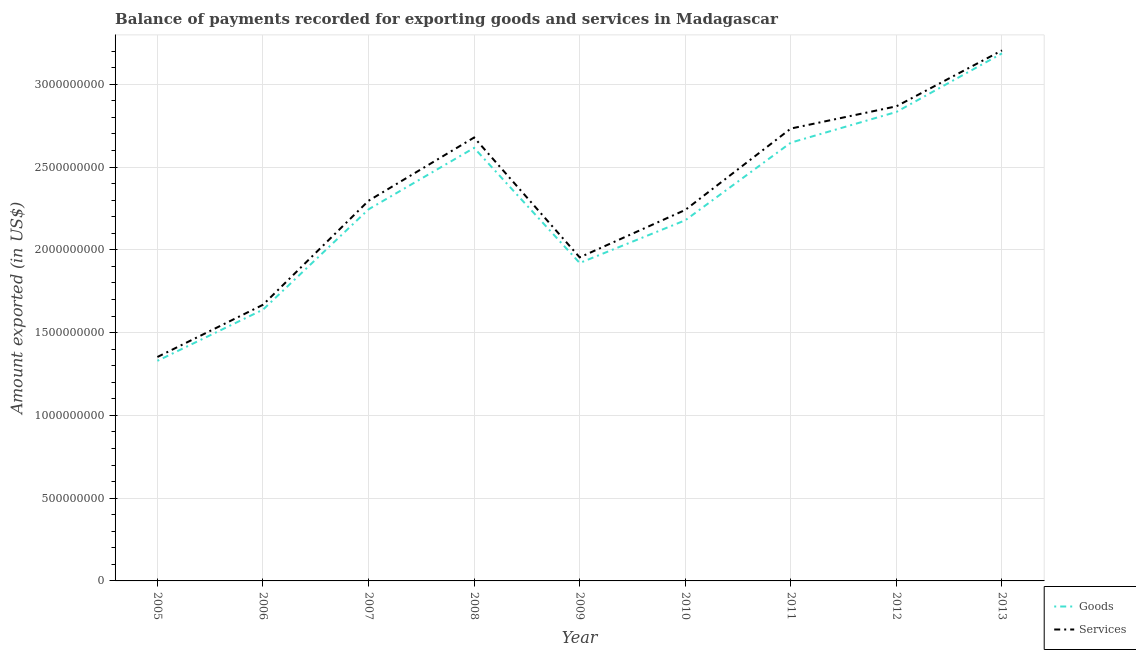Is the number of lines equal to the number of legend labels?
Your answer should be very brief. Yes. What is the amount of goods exported in 2005?
Ensure brevity in your answer.  1.33e+09. Across all years, what is the maximum amount of goods exported?
Give a very brief answer. 3.19e+09. Across all years, what is the minimum amount of goods exported?
Keep it short and to the point. 1.33e+09. What is the total amount of services exported in the graph?
Provide a short and direct response. 2.10e+1. What is the difference between the amount of goods exported in 2008 and that in 2010?
Keep it short and to the point. 4.37e+08. What is the difference between the amount of goods exported in 2007 and the amount of services exported in 2011?
Your response must be concise. -4.88e+08. What is the average amount of goods exported per year?
Keep it short and to the point. 2.29e+09. In the year 2013, what is the difference between the amount of goods exported and amount of services exported?
Keep it short and to the point. -1.80e+07. What is the ratio of the amount of goods exported in 2008 to that in 2009?
Provide a short and direct response. 1.36. Is the difference between the amount of services exported in 2009 and 2010 greater than the difference between the amount of goods exported in 2009 and 2010?
Offer a very short reply. No. What is the difference between the highest and the second highest amount of goods exported?
Give a very brief answer. 3.54e+08. What is the difference between the highest and the lowest amount of goods exported?
Your answer should be compact. 1.86e+09. In how many years, is the amount of services exported greater than the average amount of services exported taken over all years?
Give a very brief answer. 4. Is the sum of the amount of services exported in 2007 and 2010 greater than the maximum amount of goods exported across all years?
Provide a succinct answer. Yes. Does the amount of services exported monotonically increase over the years?
Provide a short and direct response. No. Is the amount of services exported strictly less than the amount of goods exported over the years?
Keep it short and to the point. No. How many lines are there?
Make the answer very short. 2. Does the graph contain any zero values?
Offer a terse response. No. Where does the legend appear in the graph?
Your answer should be very brief. Bottom right. How many legend labels are there?
Your answer should be very brief. 2. How are the legend labels stacked?
Ensure brevity in your answer.  Vertical. What is the title of the graph?
Provide a short and direct response. Balance of payments recorded for exporting goods and services in Madagascar. What is the label or title of the X-axis?
Give a very brief answer. Year. What is the label or title of the Y-axis?
Provide a succinct answer. Amount exported (in US$). What is the Amount exported (in US$) of Goods in 2005?
Make the answer very short. 1.33e+09. What is the Amount exported (in US$) in Services in 2005?
Your response must be concise. 1.35e+09. What is the Amount exported (in US$) of Goods in 2006?
Offer a terse response. 1.64e+09. What is the Amount exported (in US$) in Services in 2006?
Provide a succinct answer. 1.67e+09. What is the Amount exported (in US$) in Goods in 2007?
Offer a very short reply. 2.24e+09. What is the Amount exported (in US$) of Services in 2007?
Provide a succinct answer. 2.30e+09. What is the Amount exported (in US$) in Goods in 2008?
Your answer should be compact. 2.62e+09. What is the Amount exported (in US$) in Services in 2008?
Provide a succinct answer. 2.68e+09. What is the Amount exported (in US$) in Goods in 2009?
Keep it short and to the point. 1.92e+09. What is the Amount exported (in US$) of Services in 2009?
Keep it short and to the point. 1.95e+09. What is the Amount exported (in US$) of Goods in 2010?
Your response must be concise. 2.18e+09. What is the Amount exported (in US$) of Services in 2010?
Offer a terse response. 2.24e+09. What is the Amount exported (in US$) of Goods in 2011?
Offer a terse response. 2.65e+09. What is the Amount exported (in US$) of Services in 2011?
Ensure brevity in your answer.  2.73e+09. What is the Amount exported (in US$) in Goods in 2012?
Offer a very short reply. 2.83e+09. What is the Amount exported (in US$) in Services in 2012?
Make the answer very short. 2.87e+09. What is the Amount exported (in US$) in Goods in 2013?
Offer a very short reply. 3.19e+09. What is the Amount exported (in US$) of Services in 2013?
Make the answer very short. 3.20e+09. Across all years, what is the maximum Amount exported (in US$) in Goods?
Provide a short and direct response. 3.19e+09. Across all years, what is the maximum Amount exported (in US$) of Services?
Ensure brevity in your answer.  3.20e+09. Across all years, what is the minimum Amount exported (in US$) in Goods?
Offer a terse response. 1.33e+09. Across all years, what is the minimum Amount exported (in US$) of Services?
Provide a short and direct response. 1.35e+09. What is the total Amount exported (in US$) in Goods in the graph?
Provide a short and direct response. 2.06e+1. What is the total Amount exported (in US$) of Services in the graph?
Provide a succinct answer. 2.10e+1. What is the difference between the Amount exported (in US$) in Goods in 2005 and that in 2006?
Ensure brevity in your answer.  -3.09e+08. What is the difference between the Amount exported (in US$) in Services in 2005 and that in 2006?
Your answer should be very brief. -3.15e+08. What is the difference between the Amount exported (in US$) in Goods in 2005 and that in 2007?
Your answer should be compact. -9.15e+08. What is the difference between the Amount exported (in US$) in Services in 2005 and that in 2007?
Offer a terse response. -9.44e+08. What is the difference between the Amount exported (in US$) in Goods in 2005 and that in 2008?
Ensure brevity in your answer.  -1.29e+09. What is the difference between the Amount exported (in US$) of Services in 2005 and that in 2008?
Your response must be concise. -1.33e+09. What is the difference between the Amount exported (in US$) of Goods in 2005 and that in 2009?
Your response must be concise. -5.91e+08. What is the difference between the Amount exported (in US$) in Services in 2005 and that in 2009?
Make the answer very short. -6.02e+08. What is the difference between the Amount exported (in US$) of Goods in 2005 and that in 2010?
Offer a very short reply. -8.49e+08. What is the difference between the Amount exported (in US$) in Services in 2005 and that in 2010?
Ensure brevity in your answer.  -8.88e+08. What is the difference between the Amount exported (in US$) in Goods in 2005 and that in 2011?
Provide a succinct answer. -1.32e+09. What is the difference between the Amount exported (in US$) of Services in 2005 and that in 2011?
Offer a very short reply. -1.38e+09. What is the difference between the Amount exported (in US$) in Goods in 2005 and that in 2012?
Offer a terse response. -1.50e+09. What is the difference between the Amount exported (in US$) in Services in 2005 and that in 2012?
Your answer should be compact. -1.51e+09. What is the difference between the Amount exported (in US$) in Goods in 2005 and that in 2013?
Your answer should be very brief. -1.86e+09. What is the difference between the Amount exported (in US$) in Services in 2005 and that in 2013?
Keep it short and to the point. -1.85e+09. What is the difference between the Amount exported (in US$) of Goods in 2006 and that in 2007?
Keep it short and to the point. -6.06e+08. What is the difference between the Amount exported (in US$) in Services in 2006 and that in 2007?
Your answer should be very brief. -6.28e+08. What is the difference between the Amount exported (in US$) in Goods in 2006 and that in 2008?
Your answer should be very brief. -9.77e+08. What is the difference between the Amount exported (in US$) in Services in 2006 and that in 2008?
Give a very brief answer. -1.01e+09. What is the difference between the Amount exported (in US$) in Goods in 2006 and that in 2009?
Make the answer very short. -2.82e+08. What is the difference between the Amount exported (in US$) in Services in 2006 and that in 2009?
Keep it short and to the point. -2.86e+08. What is the difference between the Amount exported (in US$) in Goods in 2006 and that in 2010?
Ensure brevity in your answer.  -5.40e+08. What is the difference between the Amount exported (in US$) of Services in 2006 and that in 2010?
Offer a very short reply. -5.73e+08. What is the difference between the Amount exported (in US$) of Goods in 2006 and that in 2011?
Provide a short and direct response. -1.01e+09. What is the difference between the Amount exported (in US$) in Services in 2006 and that in 2011?
Provide a short and direct response. -1.06e+09. What is the difference between the Amount exported (in US$) of Goods in 2006 and that in 2012?
Provide a succinct answer. -1.19e+09. What is the difference between the Amount exported (in US$) of Services in 2006 and that in 2012?
Your answer should be very brief. -1.20e+09. What is the difference between the Amount exported (in US$) in Goods in 2006 and that in 2013?
Ensure brevity in your answer.  -1.55e+09. What is the difference between the Amount exported (in US$) of Services in 2006 and that in 2013?
Provide a short and direct response. -1.54e+09. What is the difference between the Amount exported (in US$) of Goods in 2007 and that in 2008?
Your answer should be very brief. -3.71e+08. What is the difference between the Amount exported (in US$) of Services in 2007 and that in 2008?
Provide a succinct answer. -3.82e+08. What is the difference between the Amount exported (in US$) of Goods in 2007 and that in 2009?
Offer a very short reply. 3.24e+08. What is the difference between the Amount exported (in US$) of Services in 2007 and that in 2009?
Ensure brevity in your answer.  3.42e+08. What is the difference between the Amount exported (in US$) of Goods in 2007 and that in 2010?
Your answer should be compact. 6.62e+07. What is the difference between the Amount exported (in US$) of Services in 2007 and that in 2010?
Keep it short and to the point. 5.55e+07. What is the difference between the Amount exported (in US$) in Goods in 2007 and that in 2011?
Ensure brevity in your answer.  -4.03e+08. What is the difference between the Amount exported (in US$) of Services in 2007 and that in 2011?
Keep it short and to the point. -4.36e+08. What is the difference between the Amount exported (in US$) in Goods in 2007 and that in 2012?
Your answer should be very brief. -5.88e+08. What is the difference between the Amount exported (in US$) of Services in 2007 and that in 2012?
Provide a succinct answer. -5.70e+08. What is the difference between the Amount exported (in US$) of Goods in 2007 and that in 2013?
Keep it short and to the point. -9.42e+08. What is the difference between the Amount exported (in US$) of Services in 2007 and that in 2013?
Your answer should be very brief. -9.08e+08. What is the difference between the Amount exported (in US$) in Goods in 2008 and that in 2009?
Provide a succinct answer. 6.95e+08. What is the difference between the Amount exported (in US$) in Services in 2008 and that in 2009?
Provide a short and direct response. 7.24e+08. What is the difference between the Amount exported (in US$) of Goods in 2008 and that in 2010?
Provide a short and direct response. 4.37e+08. What is the difference between the Amount exported (in US$) of Services in 2008 and that in 2010?
Keep it short and to the point. 4.38e+08. What is the difference between the Amount exported (in US$) in Goods in 2008 and that in 2011?
Provide a succinct answer. -3.17e+07. What is the difference between the Amount exported (in US$) in Services in 2008 and that in 2011?
Provide a succinct answer. -5.41e+07. What is the difference between the Amount exported (in US$) in Goods in 2008 and that in 2012?
Offer a very short reply. -2.17e+08. What is the difference between the Amount exported (in US$) in Services in 2008 and that in 2012?
Give a very brief answer. -1.88e+08. What is the difference between the Amount exported (in US$) of Goods in 2008 and that in 2013?
Offer a terse response. -5.71e+08. What is the difference between the Amount exported (in US$) of Services in 2008 and that in 2013?
Offer a very short reply. -5.26e+08. What is the difference between the Amount exported (in US$) of Goods in 2009 and that in 2010?
Your answer should be compact. -2.58e+08. What is the difference between the Amount exported (in US$) in Services in 2009 and that in 2010?
Your answer should be compact. -2.87e+08. What is the difference between the Amount exported (in US$) of Goods in 2009 and that in 2011?
Your answer should be very brief. -7.27e+08. What is the difference between the Amount exported (in US$) in Services in 2009 and that in 2011?
Your response must be concise. -7.78e+08. What is the difference between the Amount exported (in US$) of Goods in 2009 and that in 2012?
Make the answer very short. -9.12e+08. What is the difference between the Amount exported (in US$) of Services in 2009 and that in 2012?
Provide a succinct answer. -9.12e+08. What is the difference between the Amount exported (in US$) of Goods in 2009 and that in 2013?
Keep it short and to the point. -1.27e+09. What is the difference between the Amount exported (in US$) in Services in 2009 and that in 2013?
Keep it short and to the point. -1.25e+09. What is the difference between the Amount exported (in US$) in Goods in 2010 and that in 2011?
Your answer should be compact. -4.69e+08. What is the difference between the Amount exported (in US$) of Services in 2010 and that in 2011?
Offer a very short reply. -4.92e+08. What is the difference between the Amount exported (in US$) of Goods in 2010 and that in 2012?
Offer a very short reply. -6.54e+08. What is the difference between the Amount exported (in US$) in Services in 2010 and that in 2012?
Your answer should be very brief. -6.26e+08. What is the difference between the Amount exported (in US$) of Goods in 2010 and that in 2013?
Ensure brevity in your answer.  -1.01e+09. What is the difference between the Amount exported (in US$) of Services in 2010 and that in 2013?
Ensure brevity in your answer.  -9.64e+08. What is the difference between the Amount exported (in US$) in Goods in 2011 and that in 2012?
Make the answer very short. -1.86e+08. What is the difference between the Amount exported (in US$) in Services in 2011 and that in 2012?
Provide a succinct answer. -1.34e+08. What is the difference between the Amount exported (in US$) of Goods in 2011 and that in 2013?
Provide a succinct answer. -5.39e+08. What is the difference between the Amount exported (in US$) in Services in 2011 and that in 2013?
Provide a succinct answer. -4.72e+08. What is the difference between the Amount exported (in US$) in Goods in 2012 and that in 2013?
Make the answer very short. -3.54e+08. What is the difference between the Amount exported (in US$) of Services in 2012 and that in 2013?
Give a very brief answer. -3.38e+08. What is the difference between the Amount exported (in US$) in Goods in 2005 and the Amount exported (in US$) in Services in 2006?
Your answer should be compact. -3.39e+08. What is the difference between the Amount exported (in US$) of Goods in 2005 and the Amount exported (in US$) of Services in 2007?
Provide a short and direct response. -9.67e+08. What is the difference between the Amount exported (in US$) in Goods in 2005 and the Amount exported (in US$) in Services in 2008?
Ensure brevity in your answer.  -1.35e+09. What is the difference between the Amount exported (in US$) of Goods in 2005 and the Amount exported (in US$) of Services in 2009?
Offer a terse response. -6.25e+08. What is the difference between the Amount exported (in US$) in Goods in 2005 and the Amount exported (in US$) in Services in 2010?
Offer a very short reply. -9.12e+08. What is the difference between the Amount exported (in US$) of Goods in 2005 and the Amount exported (in US$) of Services in 2011?
Your answer should be very brief. -1.40e+09. What is the difference between the Amount exported (in US$) of Goods in 2005 and the Amount exported (in US$) of Services in 2012?
Make the answer very short. -1.54e+09. What is the difference between the Amount exported (in US$) in Goods in 2005 and the Amount exported (in US$) in Services in 2013?
Offer a terse response. -1.88e+09. What is the difference between the Amount exported (in US$) in Goods in 2006 and the Amount exported (in US$) in Services in 2007?
Your answer should be compact. -6.58e+08. What is the difference between the Amount exported (in US$) of Goods in 2006 and the Amount exported (in US$) of Services in 2008?
Provide a short and direct response. -1.04e+09. What is the difference between the Amount exported (in US$) in Goods in 2006 and the Amount exported (in US$) in Services in 2009?
Provide a succinct answer. -3.16e+08. What is the difference between the Amount exported (in US$) in Goods in 2006 and the Amount exported (in US$) in Services in 2010?
Your answer should be compact. -6.02e+08. What is the difference between the Amount exported (in US$) in Goods in 2006 and the Amount exported (in US$) in Services in 2011?
Make the answer very short. -1.09e+09. What is the difference between the Amount exported (in US$) of Goods in 2006 and the Amount exported (in US$) of Services in 2012?
Your answer should be compact. -1.23e+09. What is the difference between the Amount exported (in US$) of Goods in 2006 and the Amount exported (in US$) of Services in 2013?
Ensure brevity in your answer.  -1.57e+09. What is the difference between the Amount exported (in US$) in Goods in 2007 and the Amount exported (in US$) in Services in 2008?
Provide a succinct answer. -4.34e+08. What is the difference between the Amount exported (in US$) of Goods in 2007 and the Amount exported (in US$) of Services in 2009?
Provide a succinct answer. 2.90e+08. What is the difference between the Amount exported (in US$) of Goods in 2007 and the Amount exported (in US$) of Services in 2010?
Provide a short and direct response. 3.66e+06. What is the difference between the Amount exported (in US$) in Goods in 2007 and the Amount exported (in US$) in Services in 2011?
Make the answer very short. -4.88e+08. What is the difference between the Amount exported (in US$) of Goods in 2007 and the Amount exported (in US$) of Services in 2012?
Provide a short and direct response. -6.22e+08. What is the difference between the Amount exported (in US$) of Goods in 2007 and the Amount exported (in US$) of Services in 2013?
Provide a succinct answer. -9.60e+08. What is the difference between the Amount exported (in US$) in Goods in 2008 and the Amount exported (in US$) in Services in 2009?
Offer a very short reply. 6.61e+08. What is the difference between the Amount exported (in US$) in Goods in 2008 and the Amount exported (in US$) in Services in 2010?
Your response must be concise. 3.75e+08. What is the difference between the Amount exported (in US$) in Goods in 2008 and the Amount exported (in US$) in Services in 2011?
Keep it short and to the point. -1.17e+08. What is the difference between the Amount exported (in US$) of Goods in 2008 and the Amount exported (in US$) of Services in 2012?
Keep it short and to the point. -2.51e+08. What is the difference between the Amount exported (in US$) of Goods in 2008 and the Amount exported (in US$) of Services in 2013?
Make the answer very short. -5.89e+08. What is the difference between the Amount exported (in US$) in Goods in 2009 and the Amount exported (in US$) in Services in 2010?
Make the answer very short. -3.20e+08. What is the difference between the Amount exported (in US$) in Goods in 2009 and the Amount exported (in US$) in Services in 2011?
Your answer should be compact. -8.12e+08. What is the difference between the Amount exported (in US$) of Goods in 2009 and the Amount exported (in US$) of Services in 2012?
Your response must be concise. -9.46e+08. What is the difference between the Amount exported (in US$) in Goods in 2009 and the Amount exported (in US$) in Services in 2013?
Ensure brevity in your answer.  -1.28e+09. What is the difference between the Amount exported (in US$) in Goods in 2010 and the Amount exported (in US$) in Services in 2011?
Your answer should be compact. -5.54e+08. What is the difference between the Amount exported (in US$) in Goods in 2010 and the Amount exported (in US$) in Services in 2012?
Provide a succinct answer. -6.88e+08. What is the difference between the Amount exported (in US$) of Goods in 2010 and the Amount exported (in US$) of Services in 2013?
Keep it short and to the point. -1.03e+09. What is the difference between the Amount exported (in US$) of Goods in 2011 and the Amount exported (in US$) of Services in 2012?
Keep it short and to the point. -2.20e+08. What is the difference between the Amount exported (in US$) of Goods in 2011 and the Amount exported (in US$) of Services in 2013?
Provide a succinct answer. -5.57e+08. What is the difference between the Amount exported (in US$) in Goods in 2012 and the Amount exported (in US$) in Services in 2013?
Keep it short and to the point. -3.72e+08. What is the average Amount exported (in US$) of Goods per year?
Offer a very short reply. 2.29e+09. What is the average Amount exported (in US$) of Services per year?
Your answer should be compact. 2.33e+09. In the year 2005, what is the difference between the Amount exported (in US$) in Goods and Amount exported (in US$) in Services?
Your response must be concise. -2.32e+07. In the year 2006, what is the difference between the Amount exported (in US$) of Goods and Amount exported (in US$) of Services?
Keep it short and to the point. -2.95e+07. In the year 2007, what is the difference between the Amount exported (in US$) in Goods and Amount exported (in US$) in Services?
Provide a short and direct response. -5.18e+07. In the year 2008, what is the difference between the Amount exported (in US$) of Goods and Amount exported (in US$) of Services?
Give a very brief answer. -6.28e+07. In the year 2009, what is the difference between the Amount exported (in US$) of Goods and Amount exported (in US$) of Services?
Provide a short and direct response. -3.39e+07. In the year 2010, what is the difference between the Amount exported (in US$) in Goods and Amount exported (in US$) in Services?
Offer a terse response. -6.25e+07. In the year 2011, what is the difference between the Amount exported (in US$) of Goods and Amount exported (in US$) of Services?
Give a very brief answer. -8.52e+07. In the year 2012, what is the difference between the Amount exported (in US$) of Goods and Amount exported (in US$) of Services?
Provide a succinct answer. -3.40e+07. In the year 2013, what is the difference between the Amount exported (in US$) of Goods and Amount exported (in US$) of Services?
Give a very brief answer. -1.80e+07. What is the ratio of the Amount exported (in US$) of Goods in 2005 to that in 2006?
Give a very brief answer. 0.81. What is the ratio of the Amount exported (in US$) in Services in 2005 to that in 2006?
Make the answer very short. 0.81. What is the ratio of the Amount exported (in US$) in Goods in 2005 to that in 2007?
Make the answer very short. 0.59. What is the ratio of the Amount exported (in US$) of Services in 2005 to that in 2007?
Your answer should be very brief. 0.59. What is the ratio of the Amount exported (in US$) of Goods in 2005 to that in 2008?
Provide a succinct answer. 0.51. What is the ratio of the Amount exported (in US$) in Services in 2005 to that in 2008?
Offer a terse response. 0.51. What is the ratio of the Amount exported (in US$) of Goods in 2005 to that in 2009?
Give a very brief answer. 0.69. What is the ratio of the Amount exported (in US$) in Services in 2005 to that in 2009?
Your answer should be compact. 0.69. What is the ratio of the Amount exported (in US$) in Goods in 2005 to that in 2010?
Offer a terse response. 0.61. What is the ratio of the Amount exported (in US$) in Services in 2005 to that in 2010?
Your answer should be very brief. 0.6. What is the ratio of the Amount exported (in US$) in Goods in 2005 to that in 2011?
Ensure brevity in your answer.  0.5. What is the ratio of the Amount exported (in US$) of Services in 2005 to that in 2011?
Give a very brief answer. 0.49. What is the ratio of the Amount exported (in US$) in Goods in 2005 to that in 2012?
Offer a terse response. 0.47. What is the ratio of the Amount exported (in US$) in Services in 2005 to that in 2012?
Offer a terse response. 0.47. What is the ratio of the Amount exported (in US$) of Goods in 2005 to that in 2013?
Provide a short and direct response. 0.42. What is the ratio of the Amount exported (in US$) in Services in 2005 to that in 2013?
Your answer should be compact. 0.42. What is the ratio of the Amount exported (in US$) of Goods in 2006 to that in 2007?
Give a very brief answer. 0.73. What is the ratio of the Amount exported (in US$) of Services in 2006 to that in 2007?
Offer a terse response. 0.73. What is the ratio of the Amount exported (in US$) of Goods in 2006 to that in 2008?
Provide a succinct answer. 0.63. What is the ratio of the Amount exported (in US$) in Services in 2006 to that in 2008?
Ensure brevity in your answer.  0.62. What is the ratio of the Amount exported (in US$) in Goods in 2006 to that in 2009?
Your answer should be compact. 0.85. What is the ratio of the Amount exported (in US$) of Services in 2006 to that in 2009?
Keep it short and to the point. 0.85. What is the ratio of the Amount exported (in US$) in Goods in 2006 to that in 2010?
Keep it short and to the point. 0.75. What is the ratio of the Amount exported (in US$) in Services in 2006 to that in 2010?
Make the answer very short. 0.74. What is the ratio of the Amount exported (in US$) in Goods in 2006 to that in 2011?
Provide a short and direct response. 0.62. What is the ratio of the Amount exported (in US$) of Services in 2006 to that in 2011?
Make the answer very short. 0.61. What is the ratio of the Amount exported (in US$) in Goods in 2006 to that in 2012?
Give a very brief answer. 0.58. What is the ratio of the Amount exported (in US$) in Services in 2006 to that in 2012?
Provide a short and direct response. 0.58. What is the ratio of the Amount exported (in US$) of Goods in 2006 to that in 2013?
Your answer should be very brief. 0.51. What is the ratio of the Amount exported (in US$) of Services in 2006 to that in 2013?
Your response must be concise. 0.52. What is the ratio of the Amount exported (in US$) in Goods in 2007 to that in 2008?
Give a very brief answer. 0.86. What is the ratio of the Amount exported (in US$) of Services in 2007 to that in 2008?
Your answer should be very brief. 0.86. What is the ratio of the Amount exported (in US$) in Goods in 2007 to that in 2009?
Offer a very short reply. 1.17. What is the ratio of the Amount exported (in US$) of Services in 2007 to that in 2009?
Offer a terse response. 1.18. What is the ratio of the Amount exported (in US$) of Goods in 2007 to that in 2010?
Provide a succinct answer. 1.03. What is the ratio of the Amount exported (in US$) of Services in 2007 to that in 2010?
Offer a very short reply. 1.02. What is the ratio of the Amount exported (in US$) of Goods in 2007 to that in 2011?
Your answer should be very brief. 0.85. What is the ratio of the Amount exported (in US$) of Services in 2007 to that in 2011?
Your answer should be very brief. 0.84. What is the ratio of the Amount exported (in US$) of Goods in 2007 to that in 2012?
Provide a succinct answer. 0.79. What is the ratio of the Amount exported (in US$) of Services in 2007 to that in 2012?
Your response must be concise. 0.8. What is the ratio of the Amount exported (in US$) of Goods in 2007 to that in 2013?
Provide a succinct answer. 0.7. What is the ratio of the Amount exported (in US$) in Services in 2007 to that in 2013?
Ensure brevity in your answer.  0.72. What is the ratio of the Amount exported (in US$) in Goods in 2008 to that in 2009?
Your answer should be compact. 1.36. What is the ratio of the Amount exported (in US$) of Services in 2008 to that in 2009?
Your response must be concise. 1.37. What is the ratio of the Amount exported (in US$) in Goods in 2008 to that in 2010?
Ensure brevity in your answer.  1.2. What is the ratio of the Amount exported (in US$) of Services in 2008 to that in 2010?
Ensure brevity in your answer.  1.2. What is the ratio of the Amount exported (in US$) in Services in 2008 to that in 2011?
Your response must be concise. 0.98. What is the ratio of the Amount exported (in US$) in Goods in 2008 to that in 2012?
Your answer should be very brief. 0.92. What is the ratio of the Amount exported (in US$) of Services in 2008 to that in 2012?
Keep it short and to the point. 0.93. What is the ratio of the Amount exported (in US$) of Goods in 2008 to that in 2013?
Make the answer very short. 0.82. What is the ratio of the Amount exported (in US$) of Services in 2008 to that in 2013?
Your answer should be very brief. 0.84. What is the ratio of the Amount exported (in US$) in Goods in 2009 to that in 2010?
Provide a short and direct response. 0.88. What is the ratio of the Amount exported (in US$) in Services in 2009 to that in 2010?
Your answer should be very brief. 0.87. What is the ratio of the Amount exported (in US$) of Goods in 2009 to that in 2011?
Offer a terse response. 0.73. What is the ratio of the Amount exported (in US$) of Services in 2009 to that in 2011?
Provide a succinct answer. 0.72. What is the ratio of the Amount exported (in US$) of Goods in 2009 to that in 2012?
Ensure brevity in your answer.  0.68. What is the ratio of the Amount exported (in US$) of Services in 2009 to that in 2012?
Keep it short and to the point. 0.68. What is the ratio of the Amount exported (in US$) of Goods in 2009 to that in 2013?
Ensure brevity in your answer.  0.6. What is the ratio of the Amount exported (in US$) of Services in 2009 to that in 2013?
Provide a succinct answer. 0.61. What is the ratio of the Amount exported (in US$) of Goods in 2010 to that in 2011?
Ensure brevity in your answer.  0.82. What is the ratio of the Amount exported (in US$) in Services in 2010 to that in 2011?
Provide a succinct answer. 0.82. What is the ratio of the Amount exported (in US$) in Goods in 2010 to that in 2012?
Your response must be concise. 0.77. What is the ratio of the Amount exported (in US$) in Services in 2010 to that in 2012?
Your answer should be compact. 0.78. What is the ratio of the Amount exported (in US$) of Goods in 2010 to that in 2013?
Keep it short and to the point. 0.68. What is the ratio of the Amount exported (in US$) in Services in 2010 to that in 2013?
Your answer should be very brief. 0.7. What is the ratio of the Amount exported (in US$) in Goods in 2011 to that in 2012?
Keep it short and to the point. 0.93. What is the ratio of the Amount exported (in US$) in Services in 2011 to that in 2012?
Keep it short and to the point. 0.95. What is the ratio of the Amount exported (in US$) of Goods in 2011 to that in 2013?
Your response must be concise. 0.83. What is the ratio of the Amount exported (in US$) in Services in 2011 to that in 2013?
Keep it short and to the point. 0.85. What is the ratio of the Amount exported (in US$) of Goods in 2012 to that in 2013?
Provide a short and direct response. 0.89. What is the ratio of the Amount exported (in US$) of Services in 2012 to that in 2013?
Offer a very short reply. 0.89. What is the difference between the highest and the second highest Amount exported (in US$) in Goods?
Ensure brevity in your answer.  3.54e+08. What is the difference between the highest and the second highest Amount exported (in US$) of Services?
Provide a succinct answer. 3.38e+08. What is the difference between the highest and the lowest Amount exported (in US$) in Goods?
Provide a succinct answer. 1.86e+09. What is the difference between the highest and the lowest Amount exported (in US$) of Services?
Keep it short and to the point. 1.85e+09. 